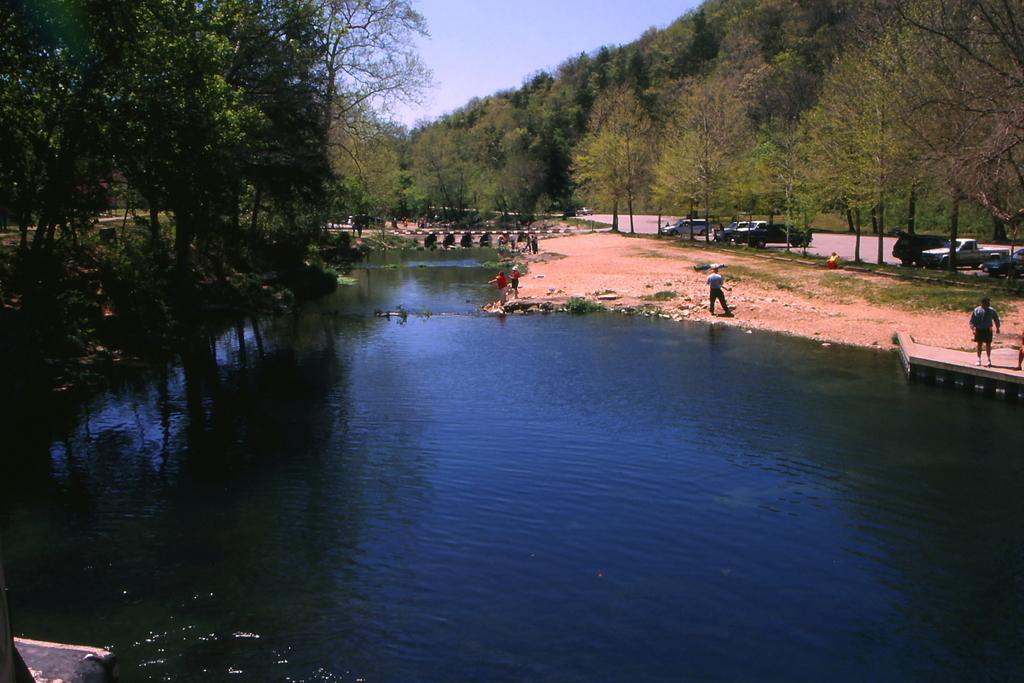In one or two sentences, can you explain what this image depicts? In this picture in the center there is water. On the left side there are trees. On the right side there are persons standing, there are cars and trees. In the background there is a pole and there are trees. 